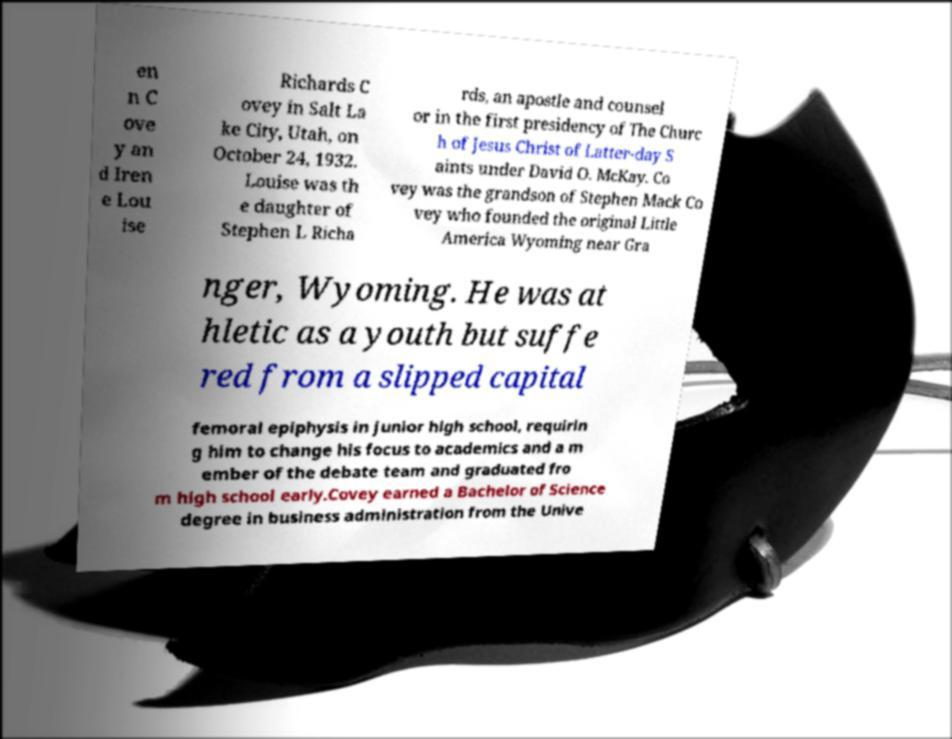What messages or text are displayed in this image? I need them in a readable, typed format. en n C ove y an d Iren e Lou ise Richards C ovey in Salt La ke City, Utah, on October 24, 1932. Louise was th e daughter of Stephen L Richa rds, an apostle and counsel or in the first presidency of The Churc h of Jesus Christ of Latter-day S aints under David O. McKay. Co vey was the grandson of Stephen Mack Co vey who founded the original Little America Wyoming near Gra nger, Wyoming. He was at hletic as a youth but suffe red from a slipped capital femoral epiphysis in junior high school, requirin g him to change his focus to academics and a m ember of the debate team and graduated fro m high school early.Covey earned a Bachelor of Science degree in business administration from the Unive 